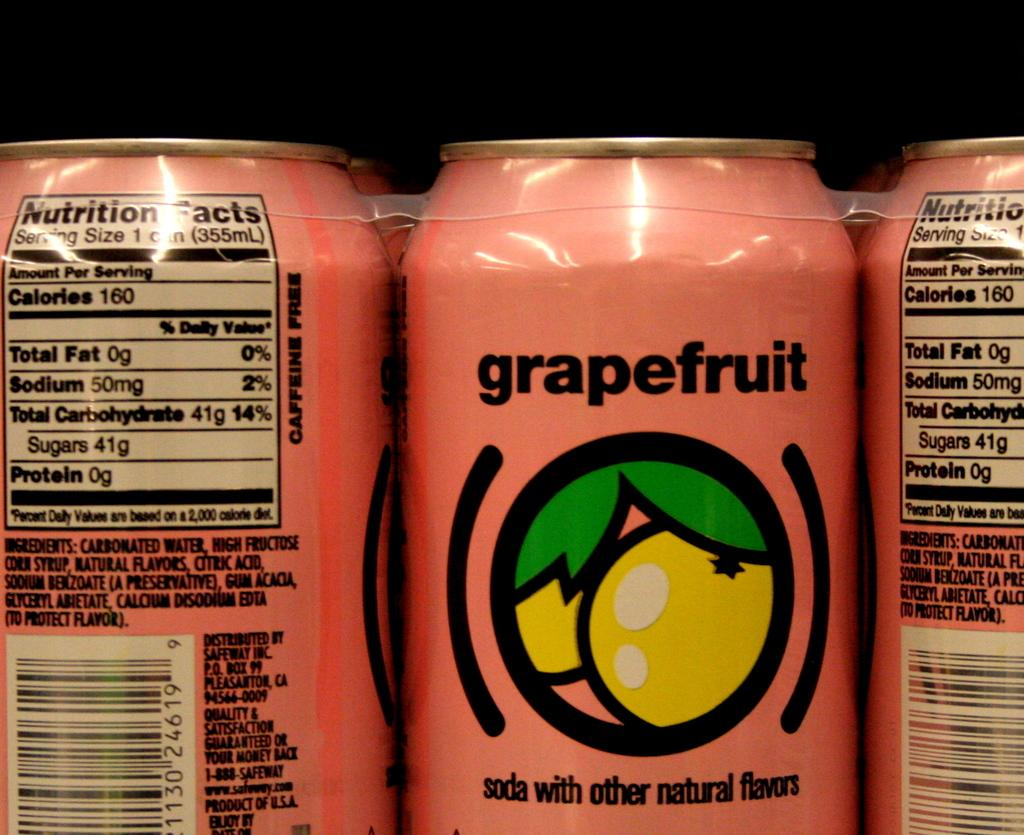<image>
Write a terse but informative summary of the picture. A pink can containing grapefruit soda sits bound to other cans waiting to be sold. 